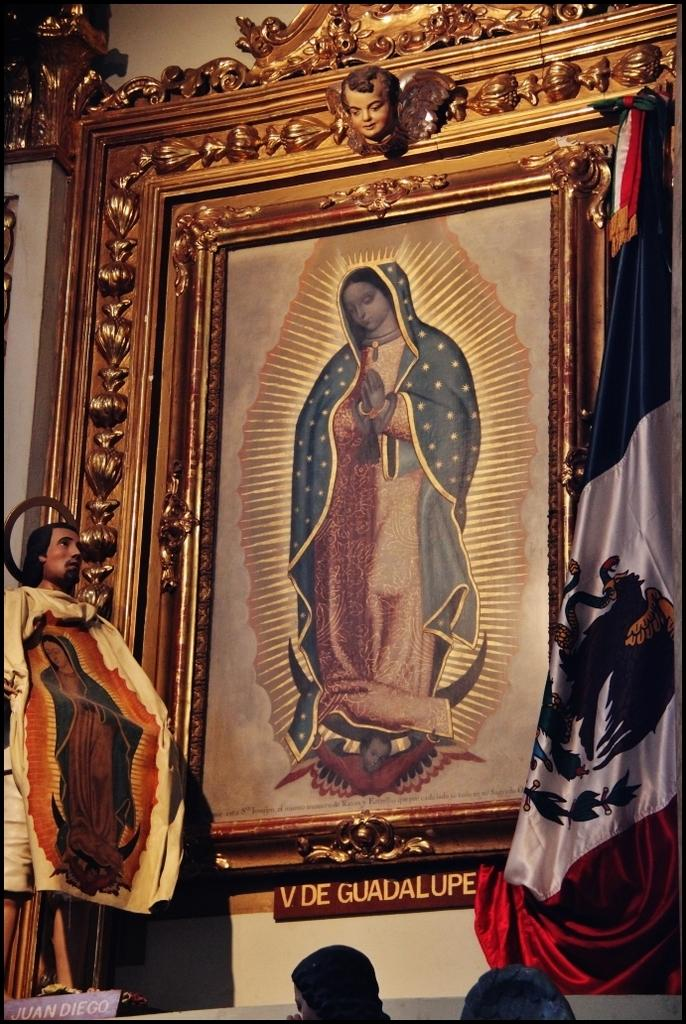What is the main object in the image? There is a frame in the image. What is attached to the frame? There is a flag in the image. What else can be seen in the image besides the frame and flag? There are boards in the image. Are there any people in the image? Yes, there is a person in the image. How many people are at the bottom of the image? There are two people at the bottom of the image. What type of mountain can be seen in the background of the image? There is no mountain visible in the image. What is your opinion on the detail of the flag in the image? The question is not about my opinion, but rather about the details of the flag in the image. The flag has a specific design and color, which can be described based on the facts provided. 